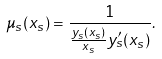Convert formula to latex. <formula><loc_0><loc_0><loc_500><loc_500>\mu _ { s } ( x _ { s } ) = \frac { 1 } { \frac { y _ { s } ( x _ { s } ) } { x _ { s } } y ^ { \prime } _ { s } ( x _ { s } ) } .</formula> 